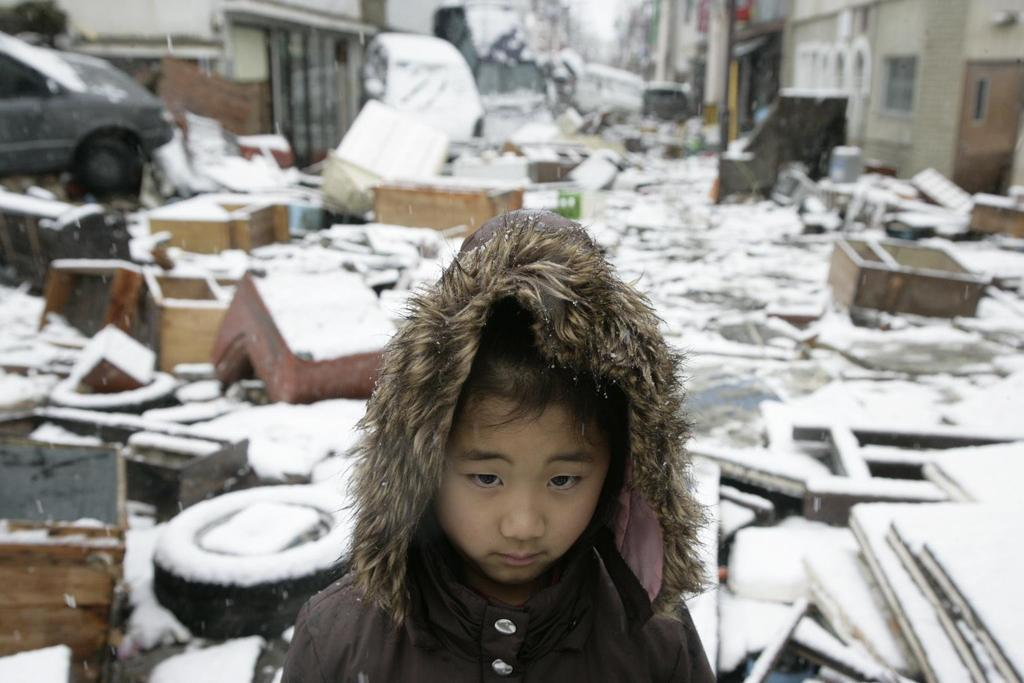Who or what is present in the image? There is a person in the image. What type of surface is visible in the image? There is ground visible in the image. What can be found on the ground in the image? There are objects and vehicles on the ground in the image. What type of structures are present in the image? There are buildings in the image. What is the weather like in the image? There is snow visible in the image, indicating a cold or wintry environment. Can you tell me how many times the person slips and falls on the snow in the image? There is no indication in the image that the person slips or falls on the snow. 